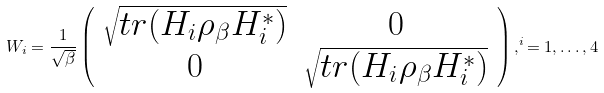<formula> <loc_0><loc_0><loc_500><loc_500>W _ { i } = \frac { 1 } { \sqrt { \beta } } \left ( \begin{array} { c c } \sqrt { t r ( H _ { i } \rho _ { \beta } H _ { i } ^ { * } ) } & 0 \\ 0 & \sqrt { t r ( H _ { i } \rho _ { \beta } H _ { i } ^ { * } ) } \end{array} \right ) , ^ { i } = 1 , \dots , 4</formula> 